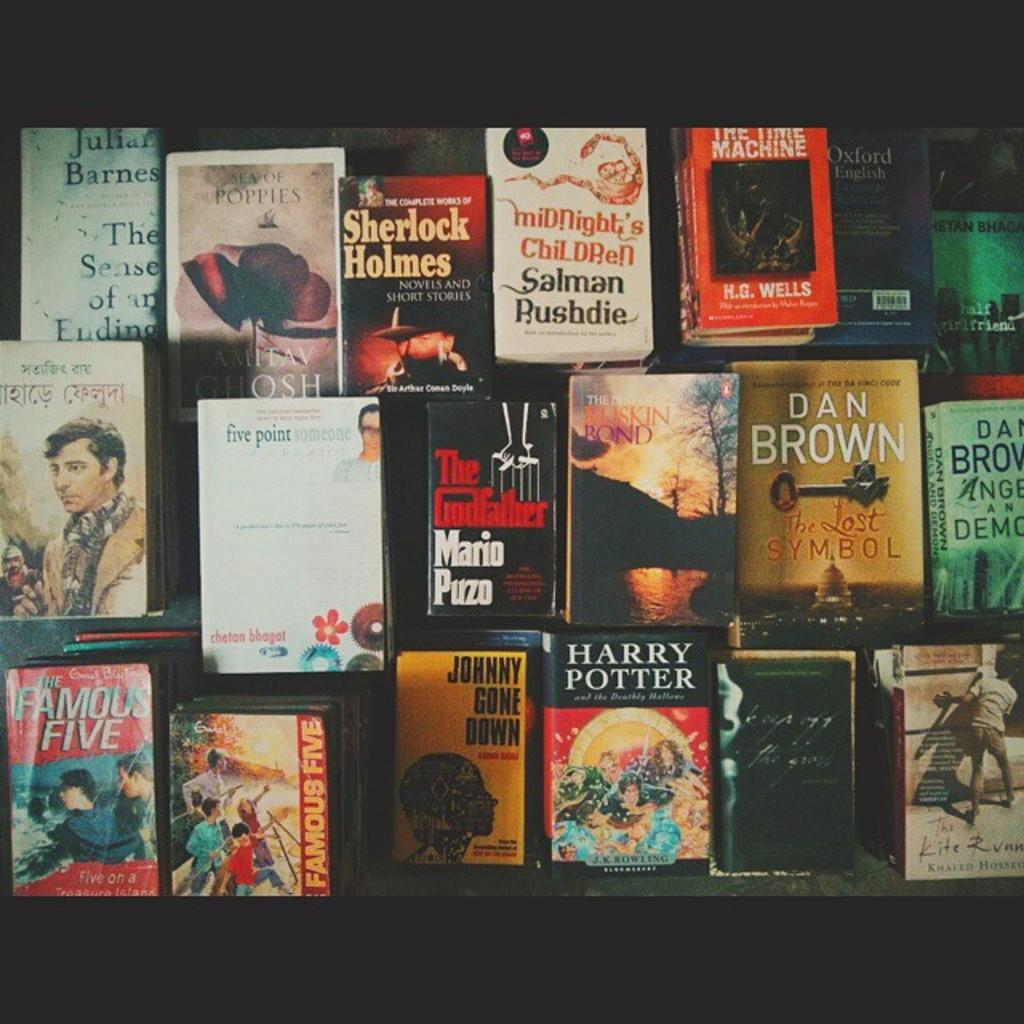<image>
Relay a brief, clear account of the picture shown. A collection of books such as Harry Potter and Dan Brown sit on a table. 